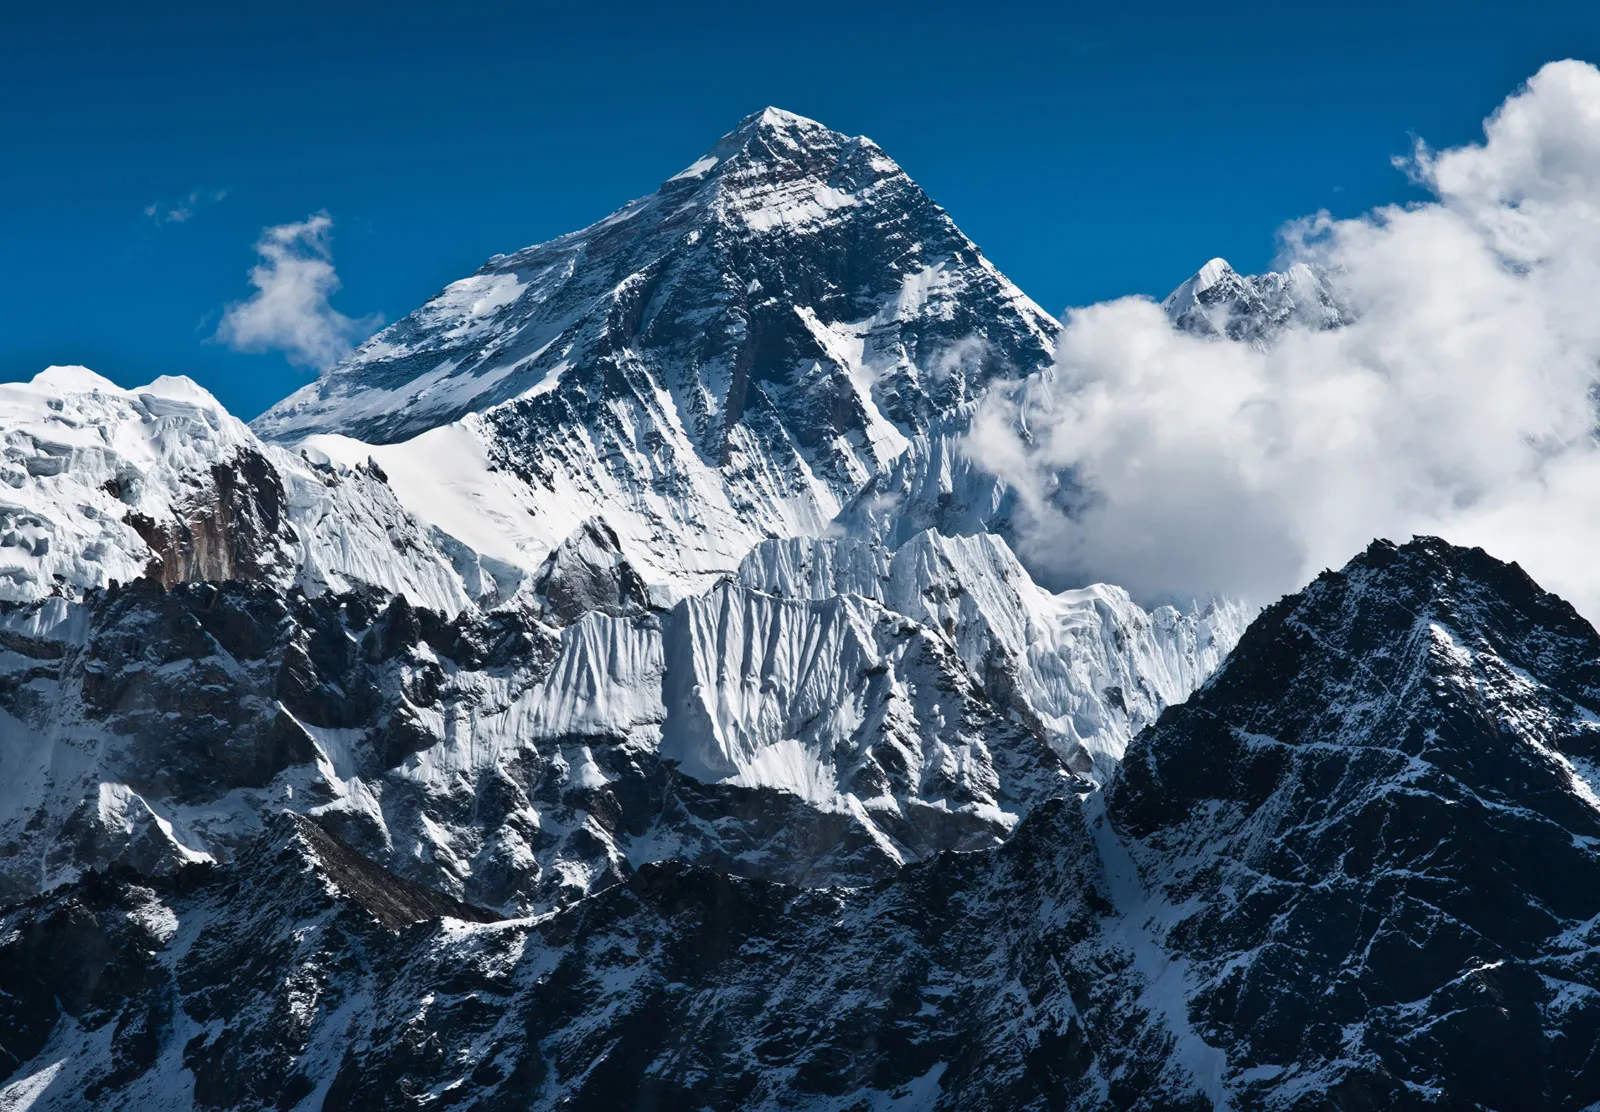Imagine standing at the top of Mount Everest. Describe the view and the feeling. Standing at the top of Mount Everest, you are greeted with an unparalleled view. The horizon stretches endlessly, a sea of billowing clouds beneath you, shrouding the world below. The peaks of the Himalayas rise like waves in a frozen ocean, dusted in a pristine layer of snow. The air is thin and crisp, making each breath a precious gift. The sensation of being on the summit is a mix of euphoria and humility, recognizing the sheer force of nature and the smallness of human endeavor. The achievement is both physical and spiritual, a testament to the human spirit and the awe-inspiring beauty of our planet. 